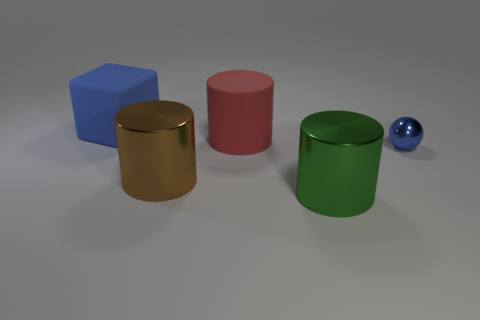Is the color of the tiny thing the same as the block?
Offer a terse response. Yes. Is the number of blue rubber things behind the big red matte thing greater than the number of green metal objects?
Your answer should be compact. No. Are any gray shiny cylinders visible?
Provide a short and direct response. No. How many things are the same size as the green cylinder?
Make the answer very short. 3. Are there more large matte cylinders that are behind the blue matte object than matte objects that are on the left side of the green cylinder?
Offer a very short reply. No. There is a red cylinder that is the same size as the brown shiny object; what material is it?
Your response must be concise. Rubber. What shape is the tiny shiny object?
Keep it short and to the point. Sphere. What number of gray things are either big matte things or small shiny balls?
Ensure brevity in your answer.  0. What is the size of the brown cylinder that is the same material as the green thing?
Offer a terse response. Large. Are the blue thing in front of the rubber cube and the blue thing that is on the left side of the green cylinder made of the same material?
Provide a short and direct response. No. 